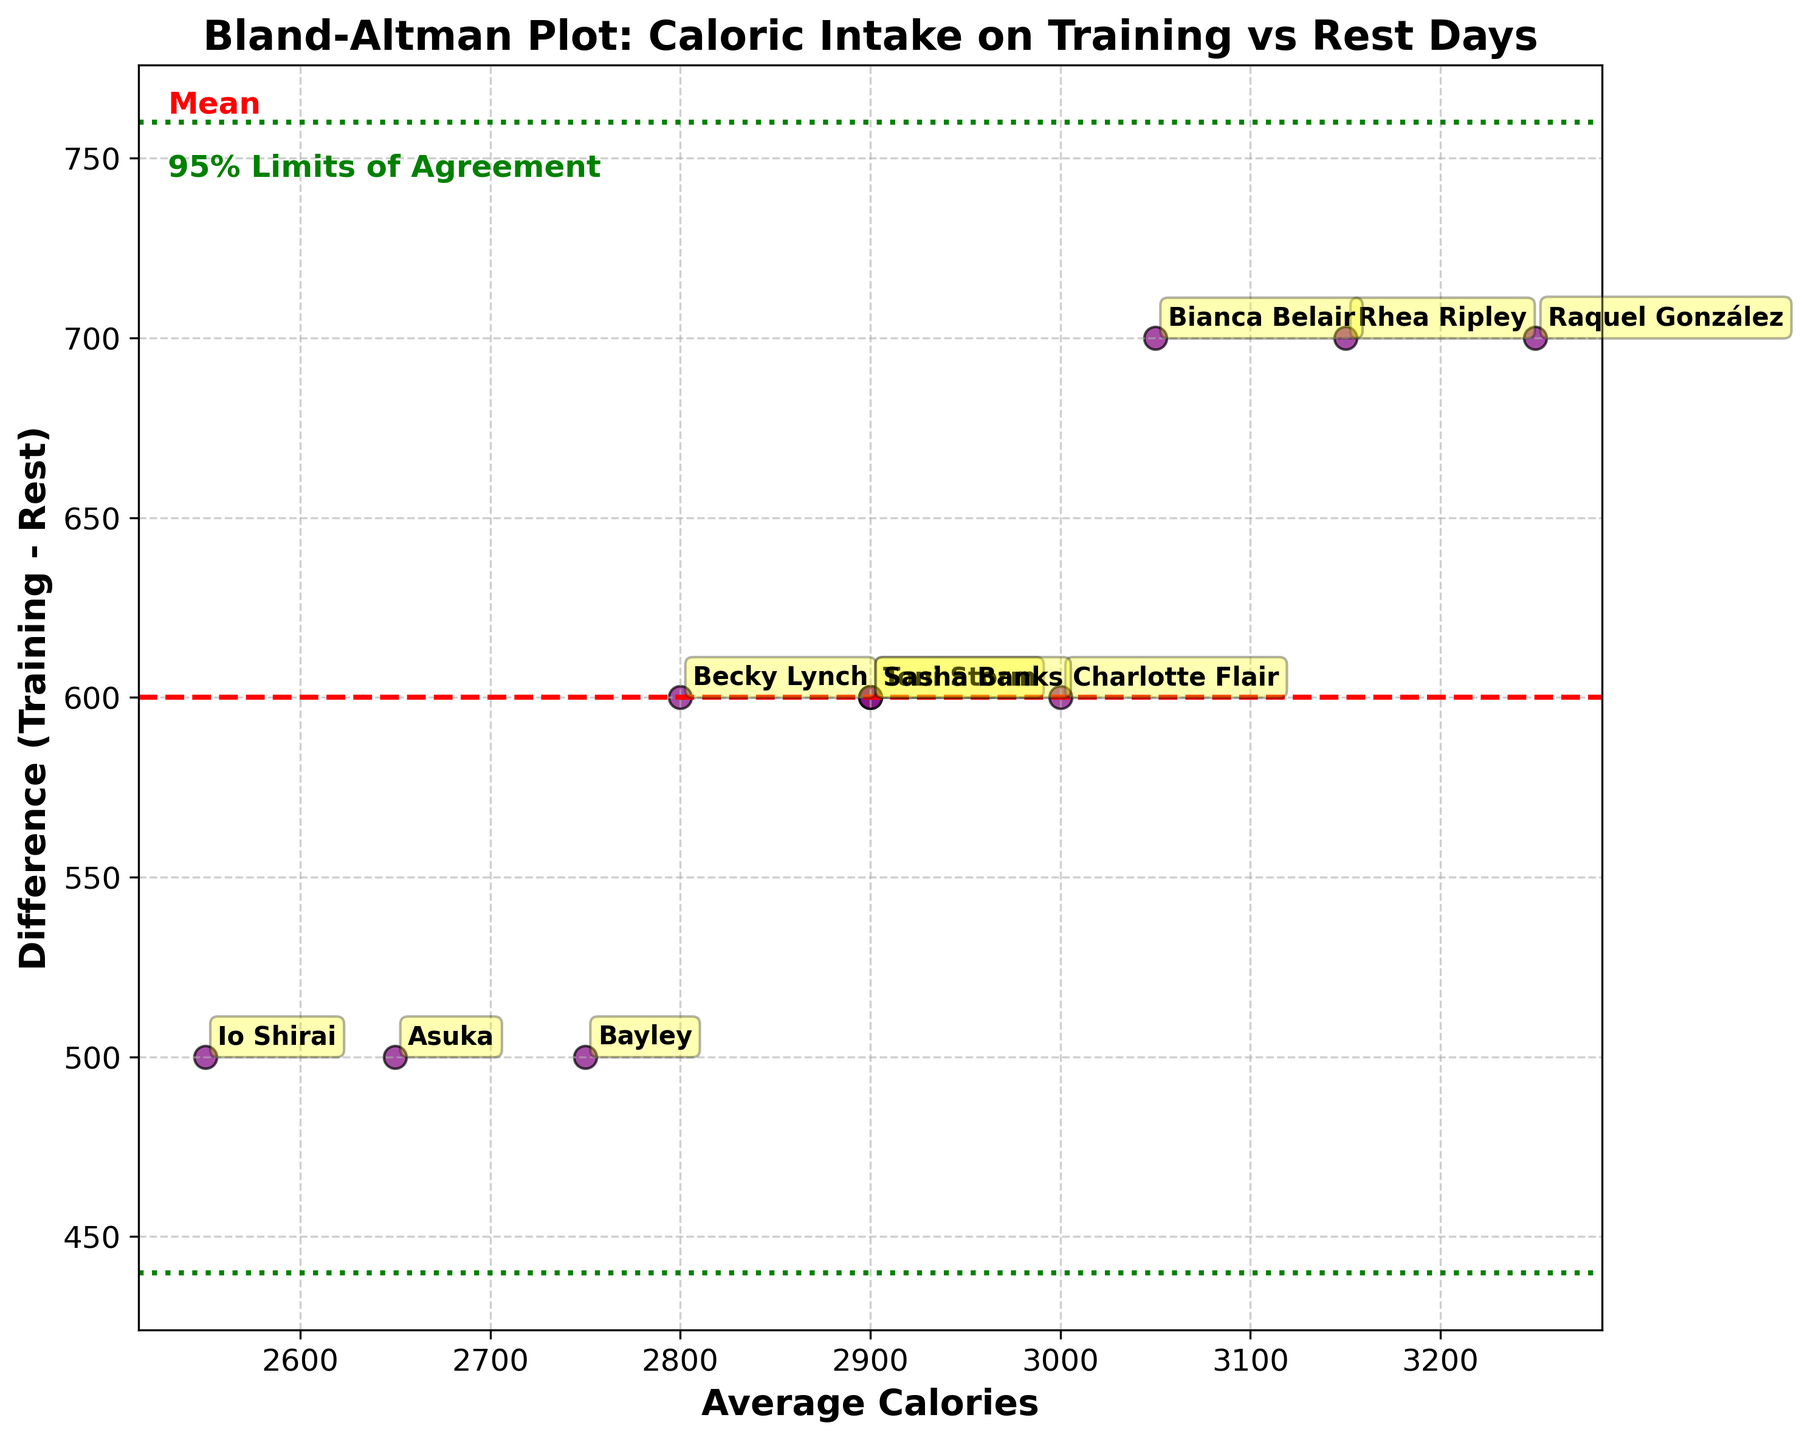What is the title of the plot? The title of the plot is located at the top of the figure and reads "Bland-Altman Plot: Caloric Intake on Training vs Rest Days". This information helps to understand what the plot is about.
Answer: Bland-Altman Plot: Caloric Intake on Training vs Rest Days What does the y-axis of the plot represent? The y-axis is labeled "Difference (Training - Rest)", which means it shows the difference in caloric intake between training days and rest days.
Answer: Difference (Training - Rest) How many green dashed lines are there, and what do they represent? There are two green dashed lines in the plot. These lines represent the 95% limits of agreement. One is above the mean difference and the other is below it, indicating the range of acceptable differences between the two sets of data.
Answer: Two, 95% limits of agreement Which wrestler has the highest average caloric intake? From the figure, observe the data points labeled with wrestlers' names along the x-axis indicating average caloric intake. Raquel González has the highest average caloric intake among all data points.
Answer: Raquel González What is the mean difference in caloric intake between training and rest days? The mean difference is represented by the red dashed line on the plot. The y-coordinate of this line shows the value, which we can deduce from its position.
Answer: Red dashed line value Which wrestlers have the same average caloric intake of 2900 calories? Look at the labels placed around the x-axis value of 2900 calories. The plotted points or annotations help to identify Toni Storm and Sasha Banks as wrestlers having an average of 2900 calories.
Answer: Toni Storm and Sasha Banks How far apart are the 95% limits of agreement from the mean difference? The 95% limits of agreement are above and below the mean difference by 1.96 times the standard deviation of the differences. From the plot, this distance can be determined by measuring the gap between the red line and the green lines. (Note: Specific values must be visually checked from the plot).
Answer: 1.96 * standard deviation Is there any wrestler whose difference in caloric intake is closest to zero? The difference between training and rest days closest to zero can be found by identifying which point is nearest to the x-axis's intersection with zero. Check the data points around the zero y-axis value and see the corresponding wrestler's name.
Answer: Closest to zero difference Which wrestlers fall outside the 95% limits of agreement? Identify the data points outside the green dashed lines. These represent wrestlers whose difference in caloric intake between training and rest days falls outside the standard range, indicating potential outliers. (Note: Must check visually from the plot).
Answer: Wrestlers outside green lines 